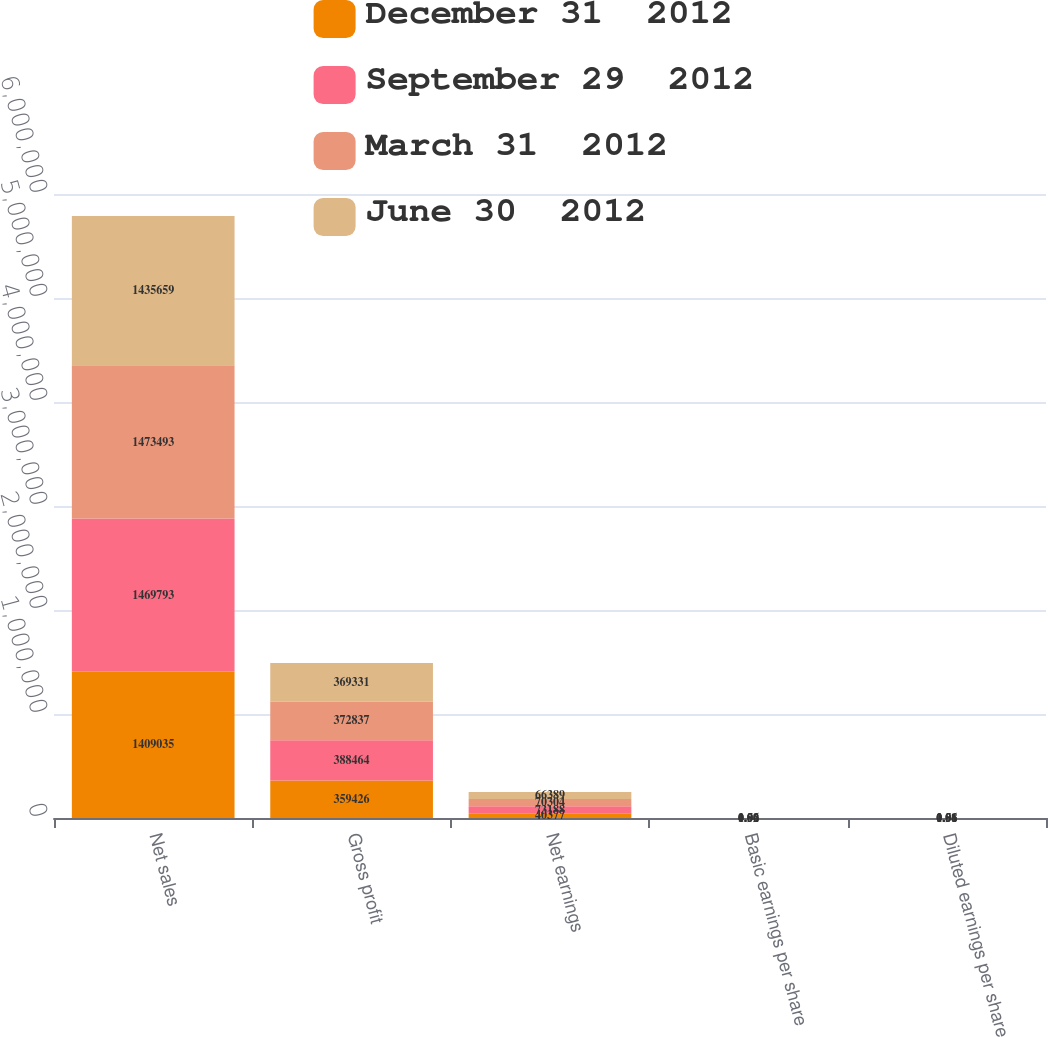Convert chart. <chart><loc_0><loc_0><loc_500><loc_500><stacked_bar_chart><ecel><fcel>Net sales<fcel>Gross profit<fcel>Net earnings<fcel>Basic earnings per share<fcel>Diluted earnings per share<nl><fcel>December 31  2012<fcel>1.40904e+06<fcel>359426<fcel>40377<fcel>0.59<fcel>0.58<nl><fcel>September 29  2012<fcel>1.46979e+06<fcel>388464<fcel>73188<fcel>1.06<fcel>1.06<nl><fcel>March 31  2012<fcel>1.47349e+06<fcel>372837<fcel>70304<fcel>1.02<fcel>1.01<nl><fcel>June 30  2012<fcel>1.43566e+06<fcel>369331<fcel>66389<fcel>0.96<fcel>0.96<nl></chart> 